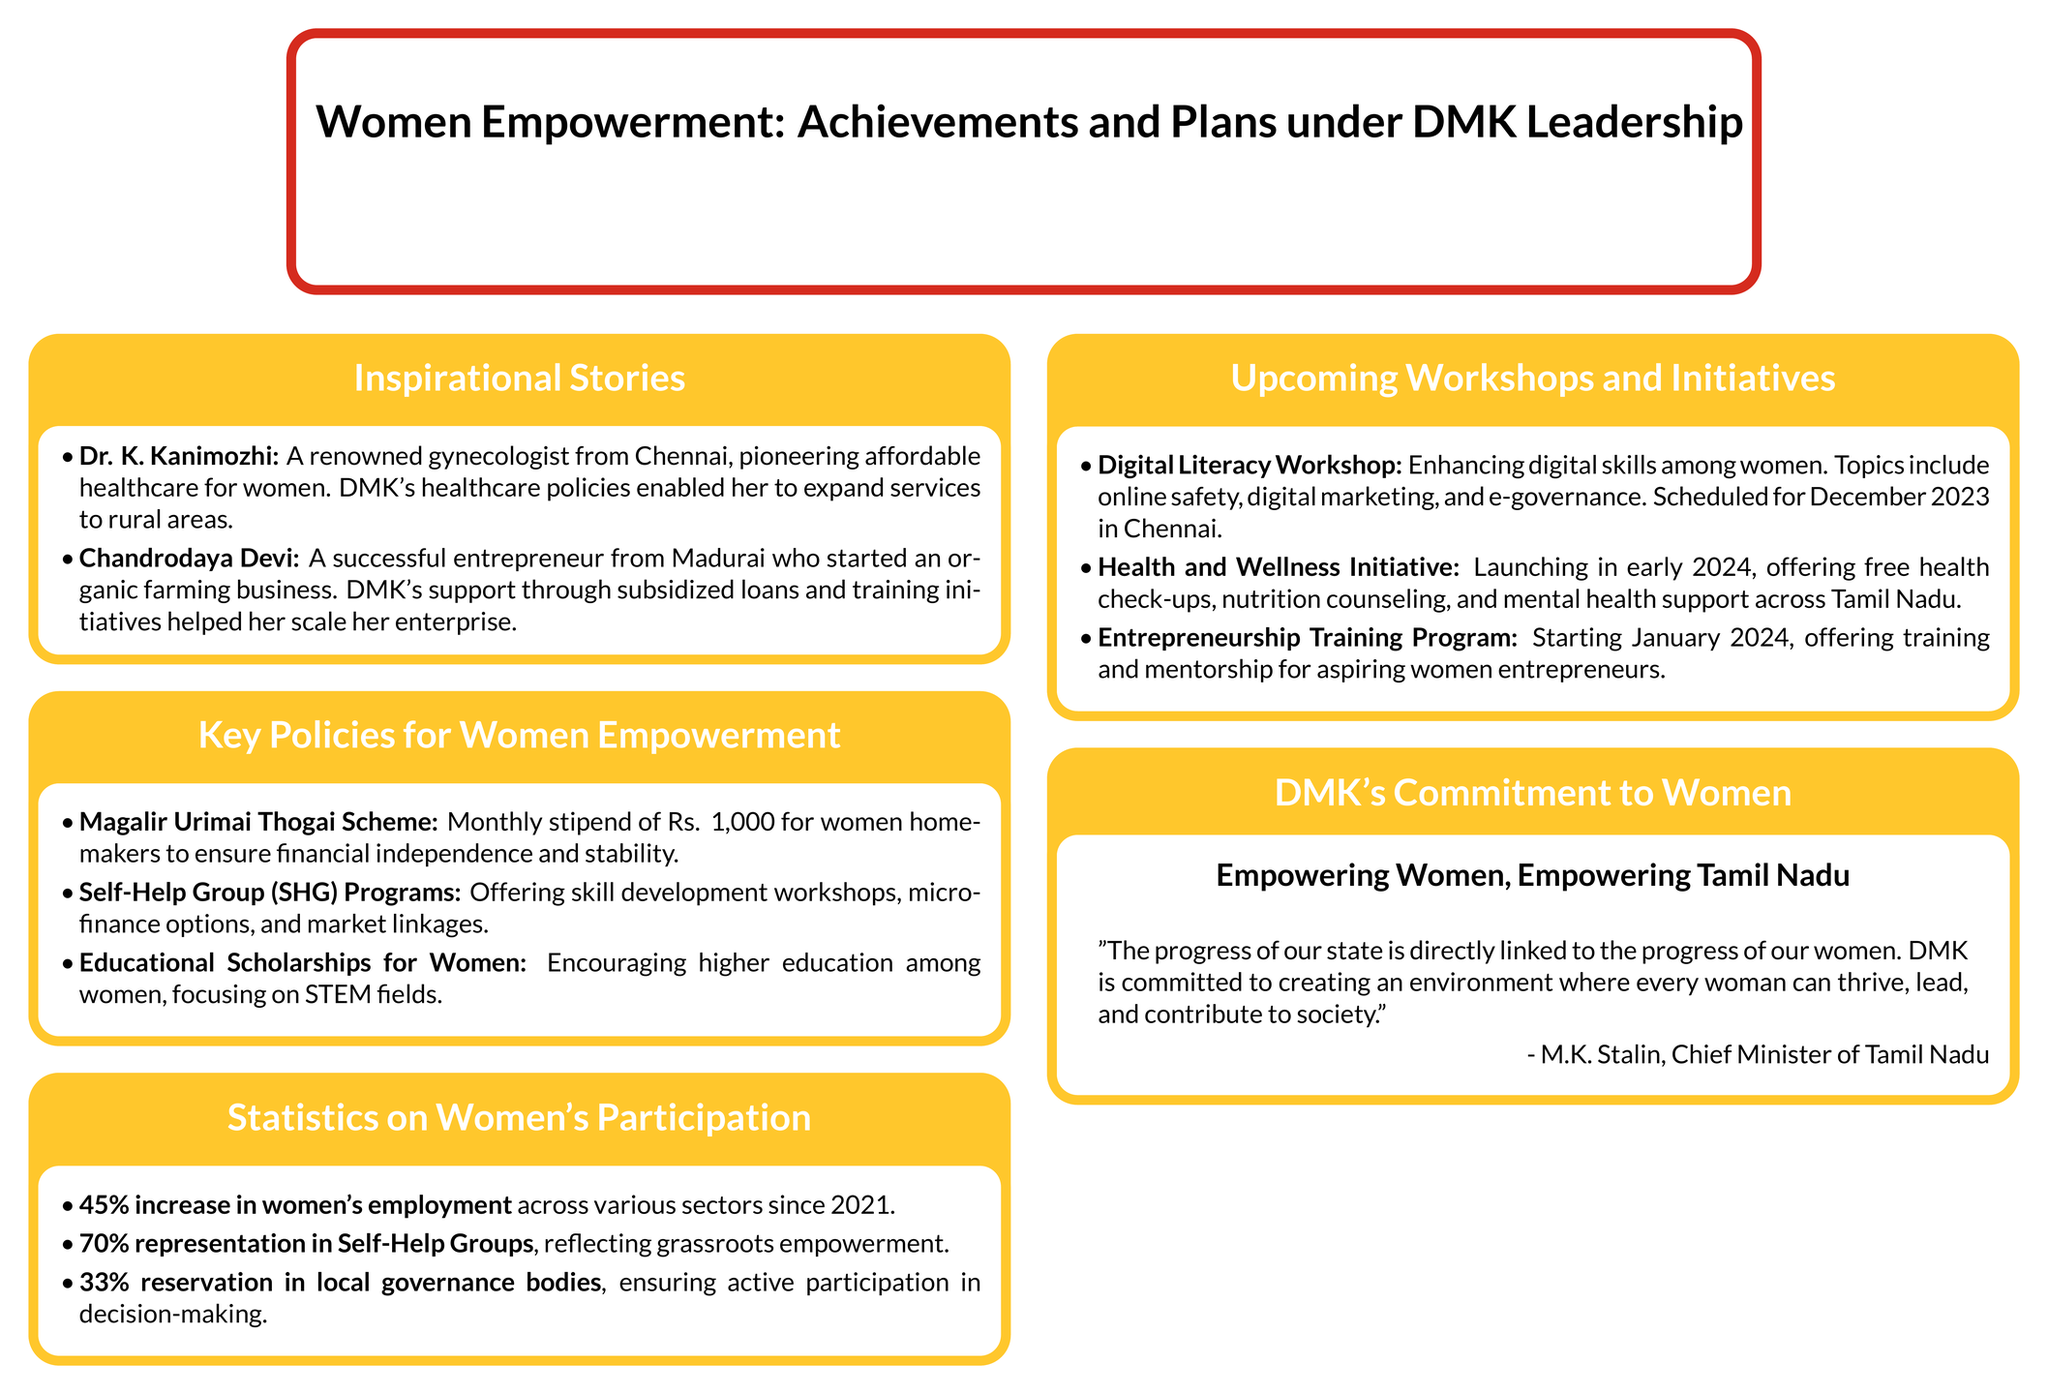What is the monthly stipend provided under the Magalir Urimai Thogai Scheme? The stipend is mentioned in the document as financial support for women homemakers.
Answer: Rs. 1,000 Who is a renowned gynecologist mentioned in the inspirational stories? The document highlights a specific individual's achievements and contributions to women's healthcare.
Answer: Dr. K. Kanimozhi What is the increase in women's employment since 2021? This statistic reflects the effectiveness of DMK's policies aimed at women's empowerment.
Answer: 45% What is one of the topics covered in the Digital Literacy Workshop? This question focuses on the specific content of the upcoming workshops mentioned in the document.
Answer: Online safety What initiative is being launched in early 2024? This question explores the upcoming plans laid out by DMK for women's support and health.
Answer: Health and Wellness Initiative What percentage of representation do women have in Self-Help Groups? This statistic highlights grassroots empowerment as mentioned in the document.
Answer: 70% Who is quoted in the commitment statement about women's empowerment? The quote emphasizes the connection between state progress and women's development.
Answer: M.K. Stalin What year is the Entrepreneurship Training Program starting? This question refers to the schedule of an initiative aimed at supporting women entrepreneurs.
Answer: January 2024 What are the statistics for local governance bodies' reservation for women? This statistic reflects the political empowerment of women as mentioned in the document.
Answer: 33% What kind of support does the Entrepreneurship Training Program offer? This question focuses on the type of assistance provided to women aspiring to become entrepreneurs.
Answer: Training and mentorship 